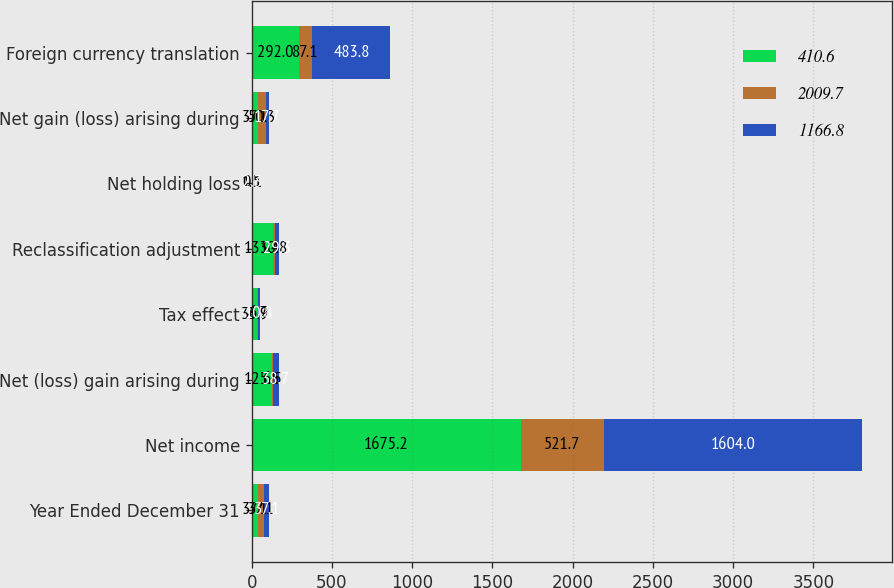Convert chart. <chart><loc_0><loc_0><loc_500><loc_500><stacked_bar_chart><ecel><fcel>Year Ended December 31<fcel>Net income<fcel>Net (loss) gain arising during<fcel>Tax effect<fcel>Reclassification adjustment<fcel>Net holding loss<fcel>Net gain (loss) arising during<fcel>Foreign currency translation<nl><fcel>410.6<fcel>37.1<fcel>1675.2<fcel>125.5<fcel>33.9<fcel>133.4<fcel>1.5<fcel>37.1<fcel>292<nl><fcel>2009.7<fcel>37.1<fcel>521.7<fcel>6.5<fcel>6.7<fcel>10.8<fcel>0.1<fcel>50.3<fcel>87.1<nl><fcel>1166.8<fcel>37.1<fcel>1604<fcel>38.7<fcel>10.8<fcel>29.3<fcel>2.3<fcel>17.7<fcel>483.8<nl></chart> 